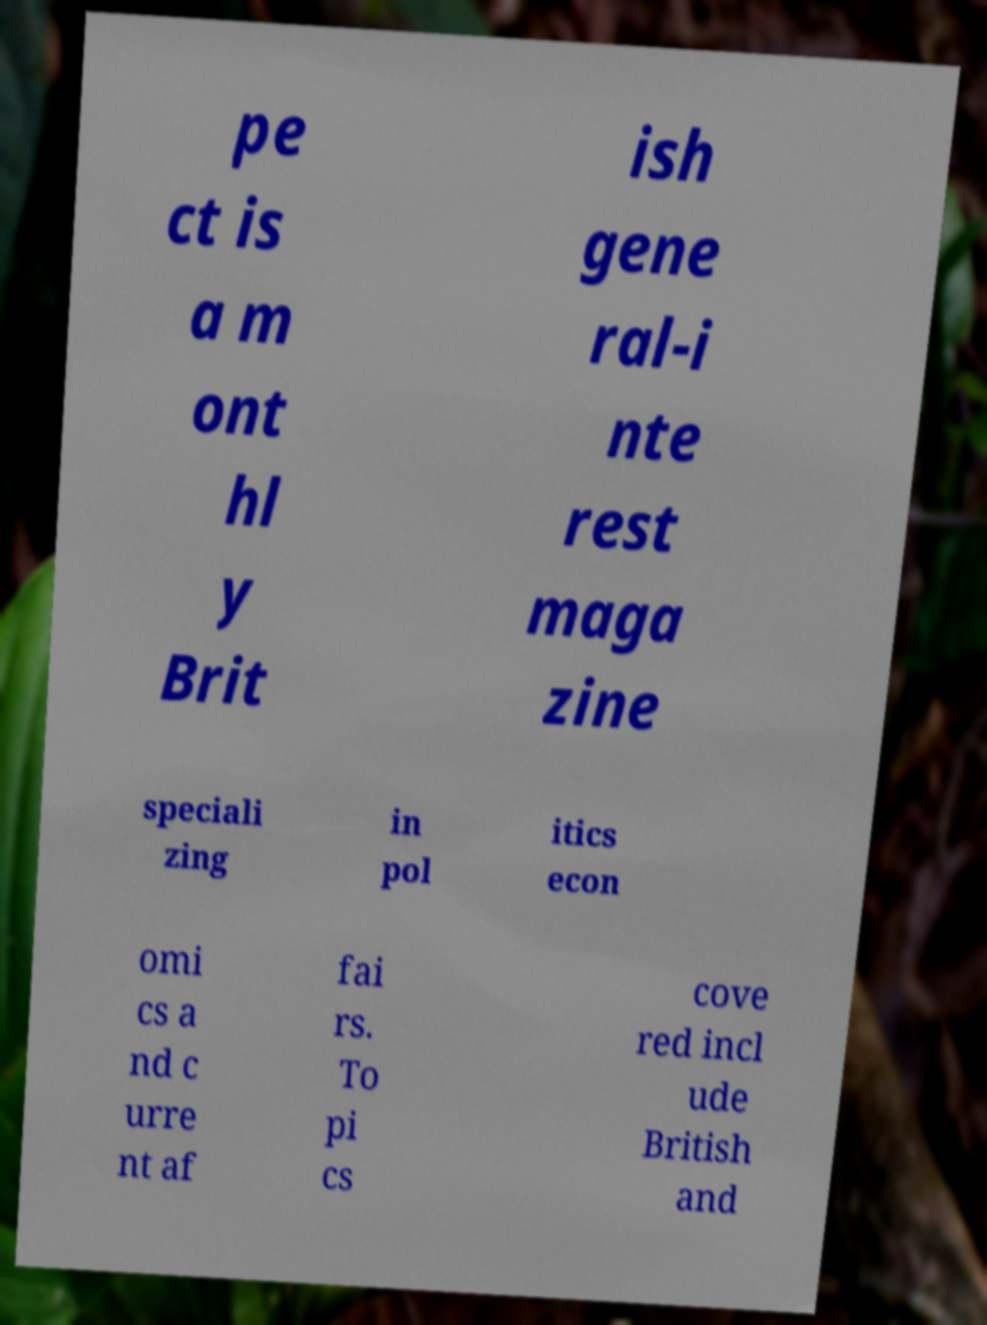Can you read and provide the text displayed in the image?This photo seems to have some interesting text. Can you extract and type it out for me? pe ct is a m ont hl y Brit ish gene ral-i nte rest maga zine speciali zing in pol itics econ omi cs a nd c urre nt af fai rs. To pi cs cove red incl ude British and 